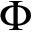<formula> <loc_0><loc_0><loc_500><loc_500>\Phi</formula> 